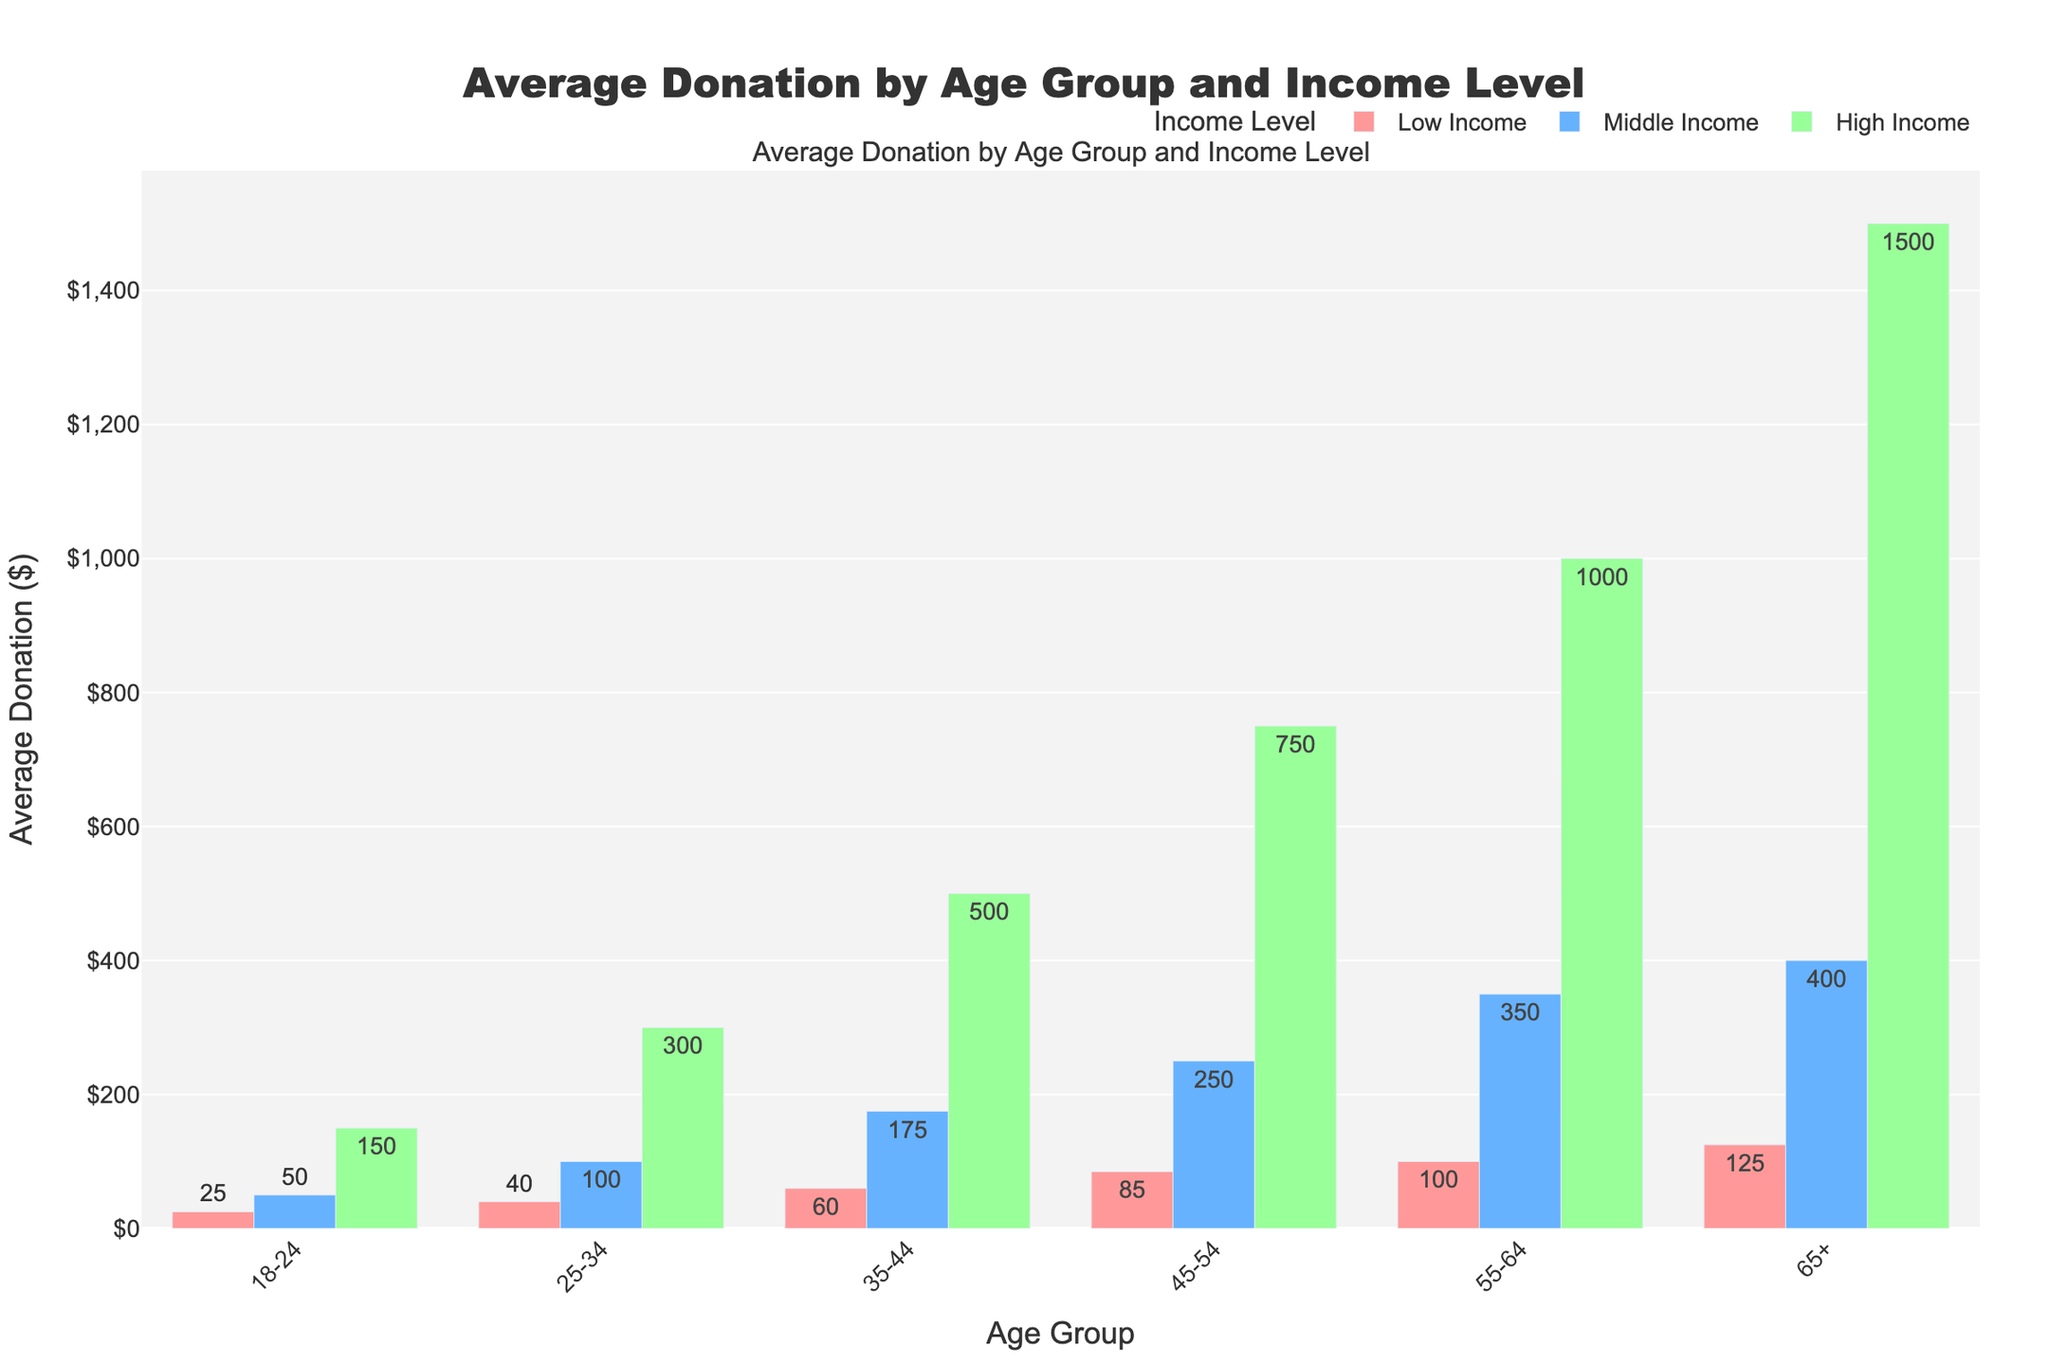What's the average donation amount for middle-income individuals across all age groups? To find the average donation amount for middle-income individuals, sum up the average donations for the middle-income level across all age groups: 50 + 100 + 175 + 250 + 350 + 400 = 1325. Then, divide by the number of age groups (6): 1325 / 6 ≈ 220.83.
Answer: 220.83 Which age group in the high-income level has the highest average donation amount? Look for the tallest bar among the high-income level bars. The highest average donation amount for high-income individuals is $1500 in the 65+ age group.
Answer: 65+ What is the difference in average donation amounts between the highest and lowest income levels in the 45-54 age group? Subtract the average donation amount of the low-income level from the high-income level for the 45-54 age group: 750 - 85 = 665.
Answer: 665 Which income level shows the greatest increase in average donation amount when moving from the 25-34 age group to the 55-64 age group? Calculate the difference in average donation amounts for each income level when moving from the 25-34 to the 55-64 age group. Low Income: 100 - 40 = 60, Middle Income: 350 - 100 = 250, High Income: 1000 - 300 = 700. The greatest increase is in the high-income level, with a difference of 700.
Answer: High Income Compare the average donation amounts for the 18-24 and 65+ age groups. Which age group has higher donations across all income levels? Compare the average donations for the 18-24 and 65+ age groups individually:
- Low Income: 18-24 ($25) vs. 65+ ($125) 
- Middle Income: 18-24 ($50) vs. 65+ ($400) 
- High Income: 18-24 ($150) vs. 65+ ($1500) 
65+ age group has higher donations across all income levels.
Answer: 65+ What is the total average donation amount for high-income individuals in the 55-64 age group and the 65+ age group? Add up the average donations for high-income individuals in the 55-64 and 65+ age groups: 1000 + 1500 = 2500.
Answer: 2500 